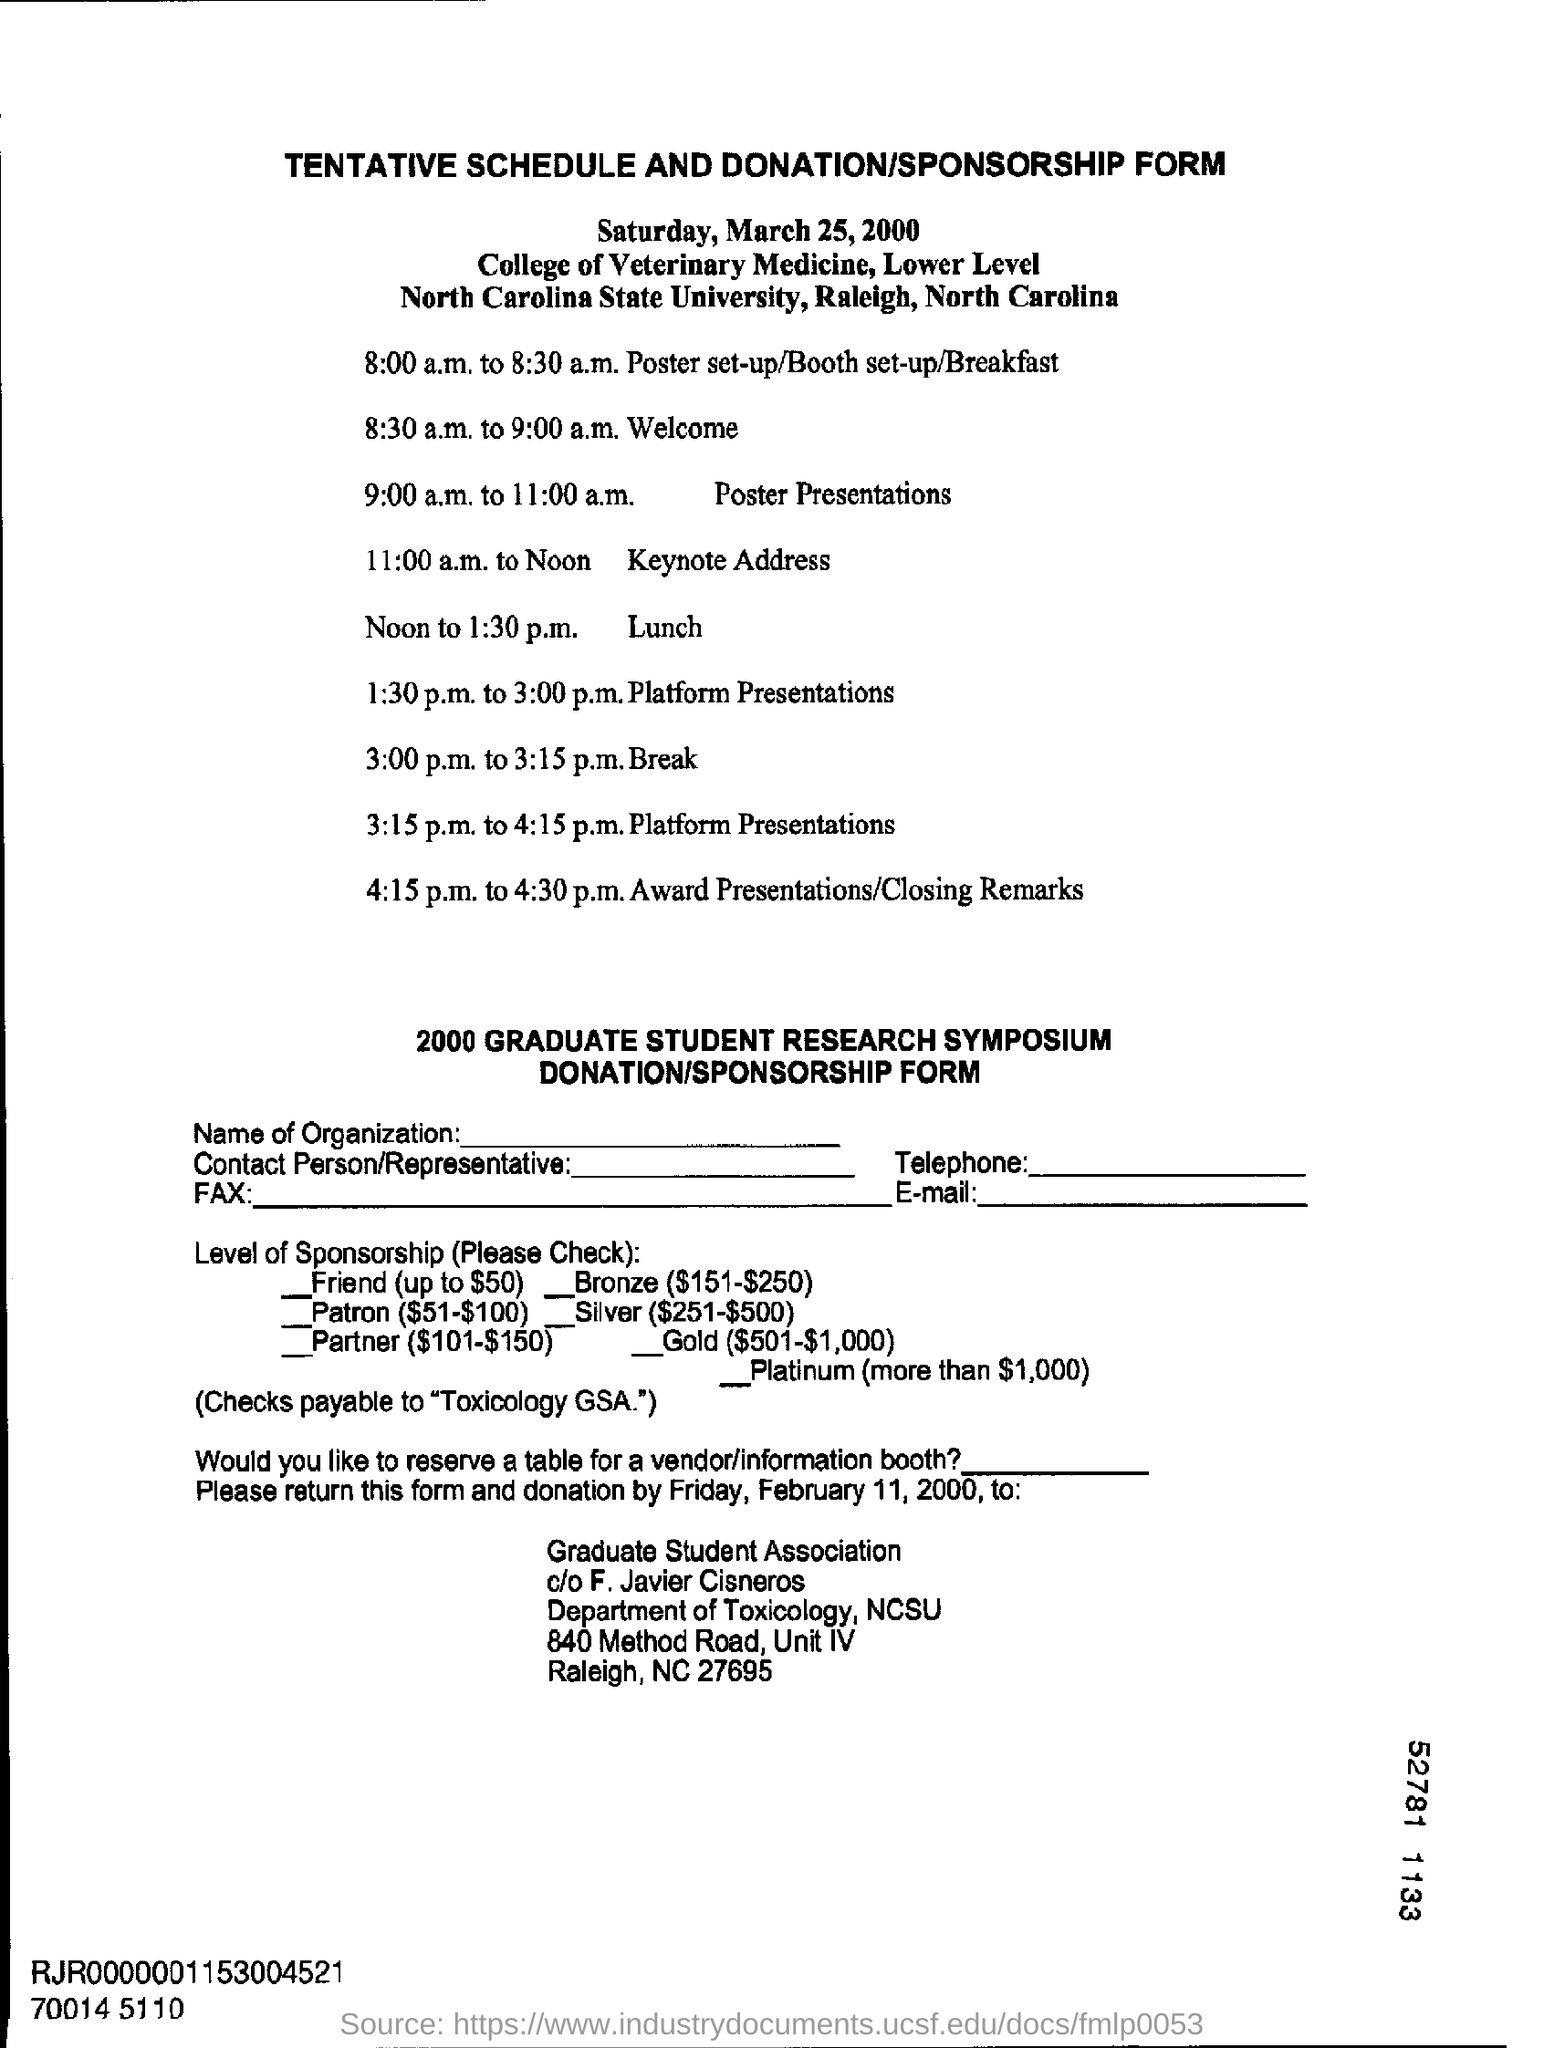Highlight a few significant elements in this photo. The lunch time is from noon to 1:30 p.m. The break timing is from 3:00 p.m. to 3:15 p.m. The date mentioned at the top of the document is Saturday, March 25, 2000. 